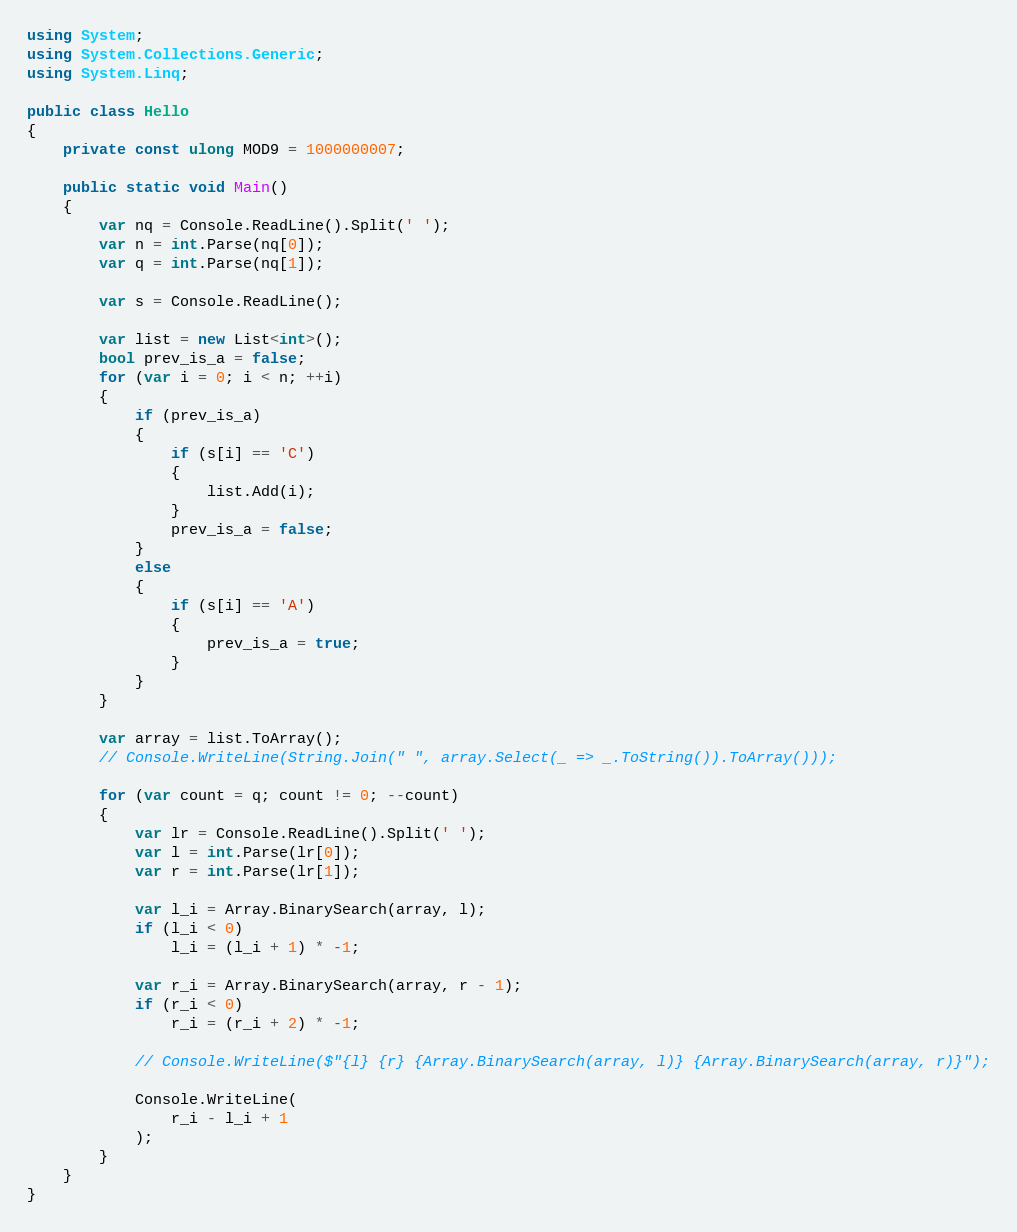<code> <loc_0><loc_0><loc_500><loc_500><_C#_>using System;
using System.Collections.Generic;
using System.Linq;

public class Hello
{
    private const ulong MOD9 = 1000000007;

    public static void Main()
    {
        var nq = Console.ReadLine().Split(' ');
        var n = int.Parse(nq[0]);
        var q = int.Parse(nq[1]);

        var s = Console.ReadLine();

        var list = new List<int>();
        bool prev_is_a = false;
        for (var i = 0; i < n; ++i)
        {
            if (prev_is_a)
            {
                if (s[i] == 'C')
                {
                    list.Add(i);
                }
                prev_is_a = false;
            }
            else
            {
                if (s[i] == 'A')
                {
                    prev_is_a = true;
                }
            }
        }

        var array = list.ToArray();
        // Console.WriteLine(String.Join(" ", array.Select(_ => _.ToString()).ToArray()));

        for (var count = q; count != 0; --count)
        {
            var lr = Console.ReadLine().Split(' ');
            var l = int.Parse(lr[0]);
            var r = int.Parse(lr[1]);

            var l_i = Array.BinarySearch(array, l);
            if (l_i < 0)
                l_i = (l_i + 1) * -1;

            var r_i = Array.BinarySearch(array, r - 1);
            if (r_i < 0)
                r_i = (r_i + 2) * -1;

            // Console.WriteLine($"{l} {r} {Array.BinarySearch(array, l)} {Array.BinarySearch(array, r)}");

            Console.WriteLine(
                r_i - l_i + 1
            );
        }
    }
}
</code> 